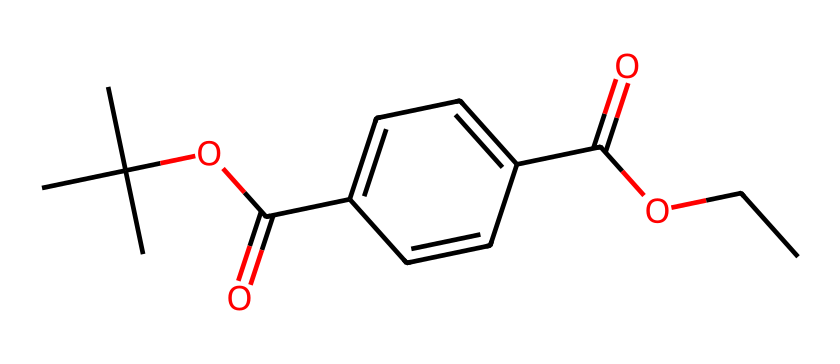What is the functional group present in this molecule? The SMILES representation shows a carbonyl group (C=O), indicated by "C(=O)" in the structure, and an ester group (RCOOR') where R and R' are carbon chains or groups.
Answer: ester How many carbon atoms are in this chemical structure? By analyzing the SMILES notation, every "C" represents a carbon atom, and from the structure, there are nine carbon atoms in total.
Answer: nine What type of polymer does polyethylene terephthalate (PET) represent? This molecule is a polyester, as the presence of ester groups links the repeating units in the polymer chain.
Answer: polyester What is the total number of oxygen atoms in this structure? Counting all occurrences of "O" in the SMILES string shows there are three oxygen atoms present in the chemical structure.
Answer: three Which part of the molecule contributes to its recycling property? The ester bonds in the structure allow for the depolymerization process during recycling, enabling PET to be broken down into its monomers.
Answer: ester bonds 